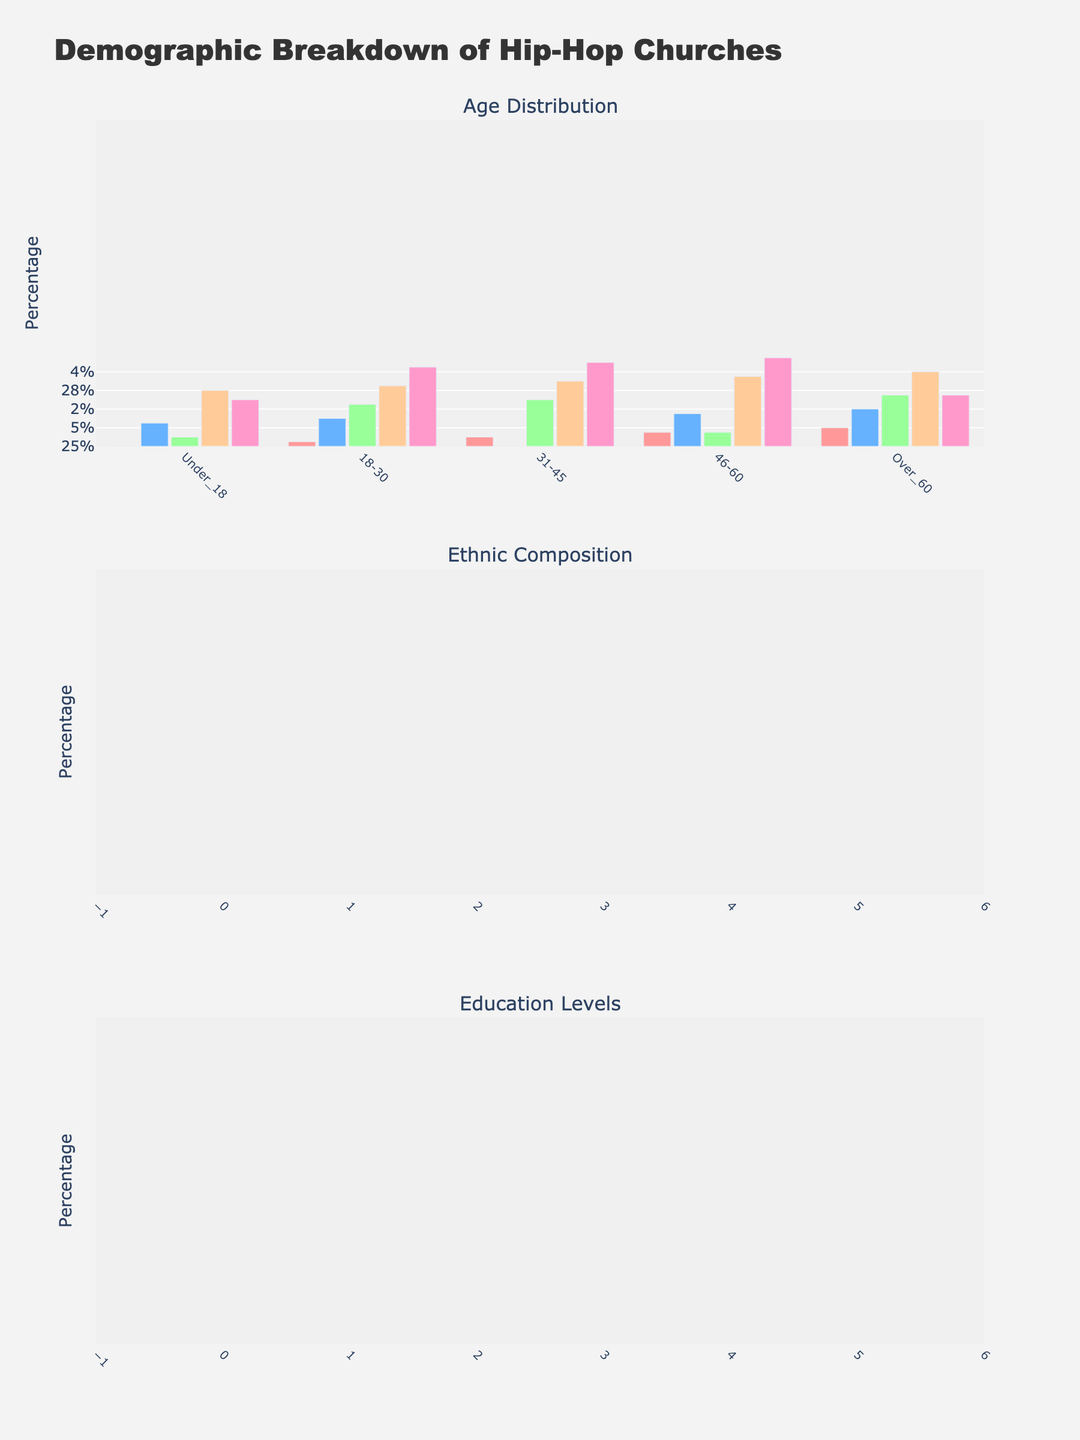How many distinct age groups are represented in the "Age Distribution" subplot? The "Age Distribution" subplot shows the breakdown of five distinct age groups: Under 18, 18-30, 31-45, 46-60, and Over 60. Each group is represented by a distinct section of the bar chart.
Answer: 5 Which church has the highest percentage of members in the 18-30 age group? By looking at the "Age Distribution" subplot, the church with the highest bar in the 18-30 age group is LA Rhythm Fellowship, clocking in at 45 percent.
Answer: LA Rhythm Fellowship What is the combined percentage of African American members in Atlanta Hip Hop Church and Chicago Flow Congregation? From the "Ethnic Composition" subplot, Atlanta Hip Hop Church has 60% African American members, and Chicago Flow Congregation has 58%. Adding these together gives 60% + 58% = 118%.
Answer: 118% Which church has the least representation in the "Other" ethnicity category? By observing the "Ethnic Composition" subplot, Houston Rap Revival, Bronxd Beats Ministry, and Chicago Flow Congregation each have 2% representation in the "Other" ethnicity category. Since three churches have the least representation in this category, we'll list all.
Answer: Houston Rap Revival, Bronxd Beats Ministry, and Chicago Flow Congregation What is the difference in the percentage of members with a Bachelor’s degree between Houston Rap Revival and Bronx Beats Ministry? In the "Education Levels" subplot, Houston Rap Revival has 22% with a Bachelor’s degree, and Bronx Beats Ministry has 22%. Calculating the difference gives us 22% - 22% = 0%.
Answer: 0% Which ethnicity category has the greatest range in membership percentages across all churches? The range can be calculated by finding the difference between the maximum and minimum values for each ethnicity category. For African American: 60% - 45% = 15%, for Hispanic: 30% - 15% = 15%, for White: 20% - 15% = 5%, for Asian: 5% - 3% = 2%, and for Other: 2% - 2% = 0%. Both African American and Hispanic have the greatest range, being 15%.
Answer: African American and Hispanic Among the displayed churches, which one exhibits the highest diversity in education levels? To analyze diversity, look for uneven distribution across categories. The "Education Levels" subplot shows that LA Rhythm Fellowship has a more evenly distributed education level across High School, Some College, Bachelor's, Master's, and Ph.D. categories relative to other churches.
Answer: LA Rhythm Fellowship What percentage of members at Chicago Flow Congregation are in the 31-45 age group? In the "Age Distribution" subplot, Chicago Flow Congregation shows 18% for the 31-45 age group.
Answer: 18% Which church appears most frequently with higher percentages in both the "Age Distribution" and "Ethnic Composition" subplots? By comparing the age and ethnic composition metrics across all churches, Atlanta Hip Hop Church often shows up at higher percentages in multiple categories (e.g., the highest percentage of Under 18 and High School education).
Answer: Atlanta Hip Hop Church 